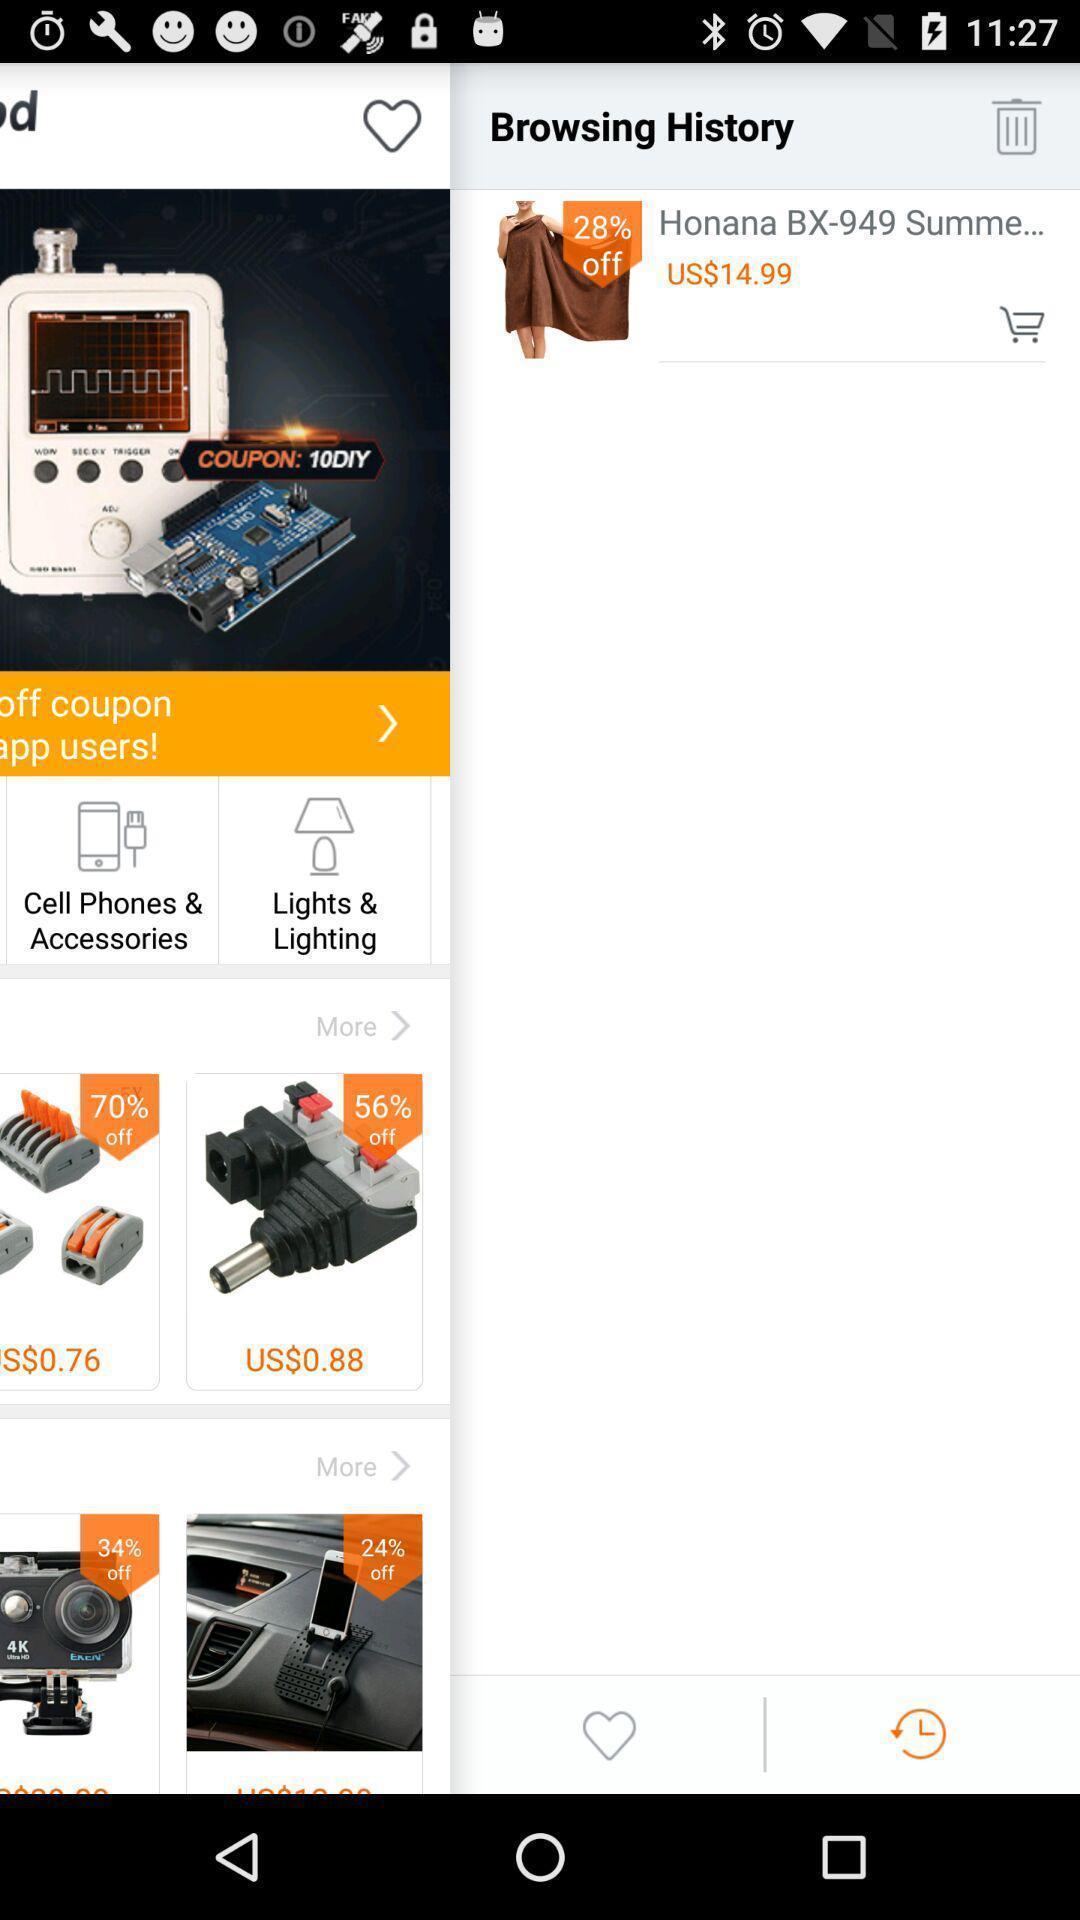Tell me about the visual elements in this screen capture. Page showing history of a shopping app. 